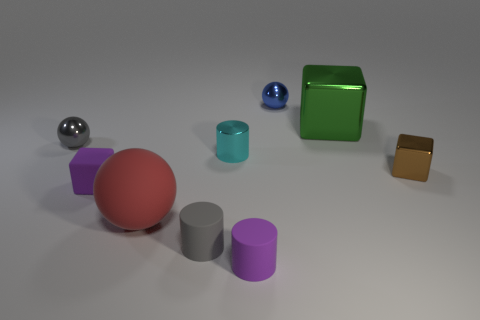If we were to group these objects by material, how would you categorize them? Objects can be grouped into two categories based on material: metallic and matte. The metallic objects include the green cube, the silver sphere, and the blue sphere. The matte objects are the purple and grey cylinders, the brown cube, and the red sphere. Which group seems to have more variety in shapes and sizes? The matte objects exhibit a greater variety in shapes and sizes, ranging from the large red sphere and differently sized cylinders to the small brown cube. 